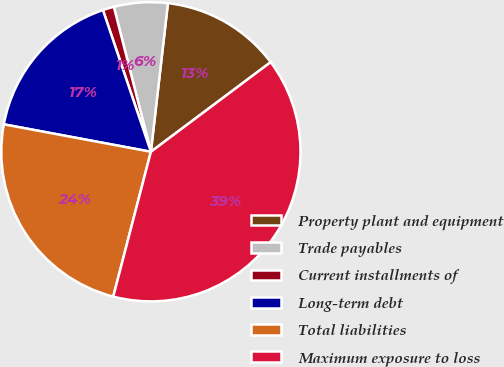Convert chart to OTSL. <chart><loc_0><loc_0><loc_500><loc_500><pie_chart><fcel>Property plant and equipment<fcel>Trade payables<fcel>Current installments of<fcel>Long-term debt<fcel>Total liabilities<fcel>Maximum exposure to loss<nl><fcel>12.96%<fcel>5.8%<fcel>1.21%<fcel>16.87%<fcel>23.89%<fcel>39.27%<nl></chart> 